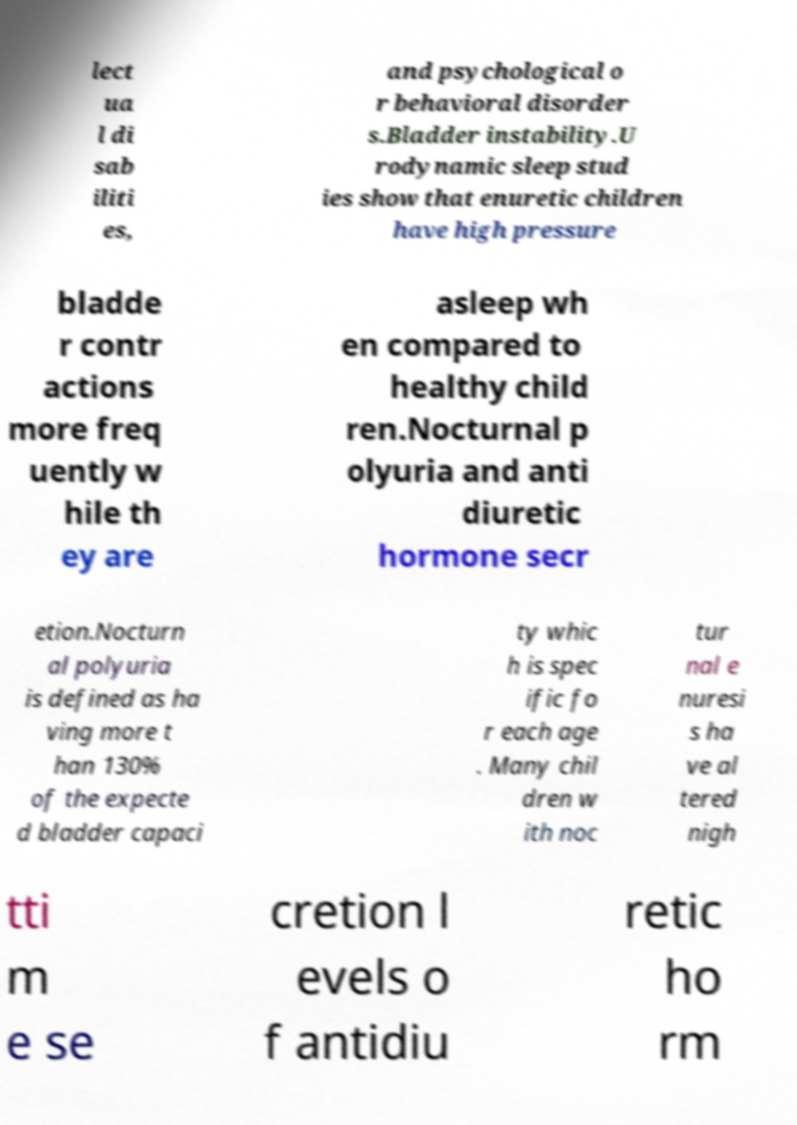Please identify and transcribe the text found in this image. lect ua l di sab iliti es, and psychological o r behavioral disorder s.Bladder instability.U rodynamic sleep stud ies show that enuretic children have high pressure bladde r contr actions more freq uently w hile th ey are asleep wh en compared to healthy child ren.Nocturnal p olyuria and anti diuretic hormone secr etion.Nocturn al polyuria is defined as ha ving more t han 130% of the expecte d bladder capaci ty whic h is spec ific fo r each age . Many chil dren w ith noc tur nal e nuresi s ha ve al tered nigh tti m e se cretion l evels o f antidiu retic ho rm 